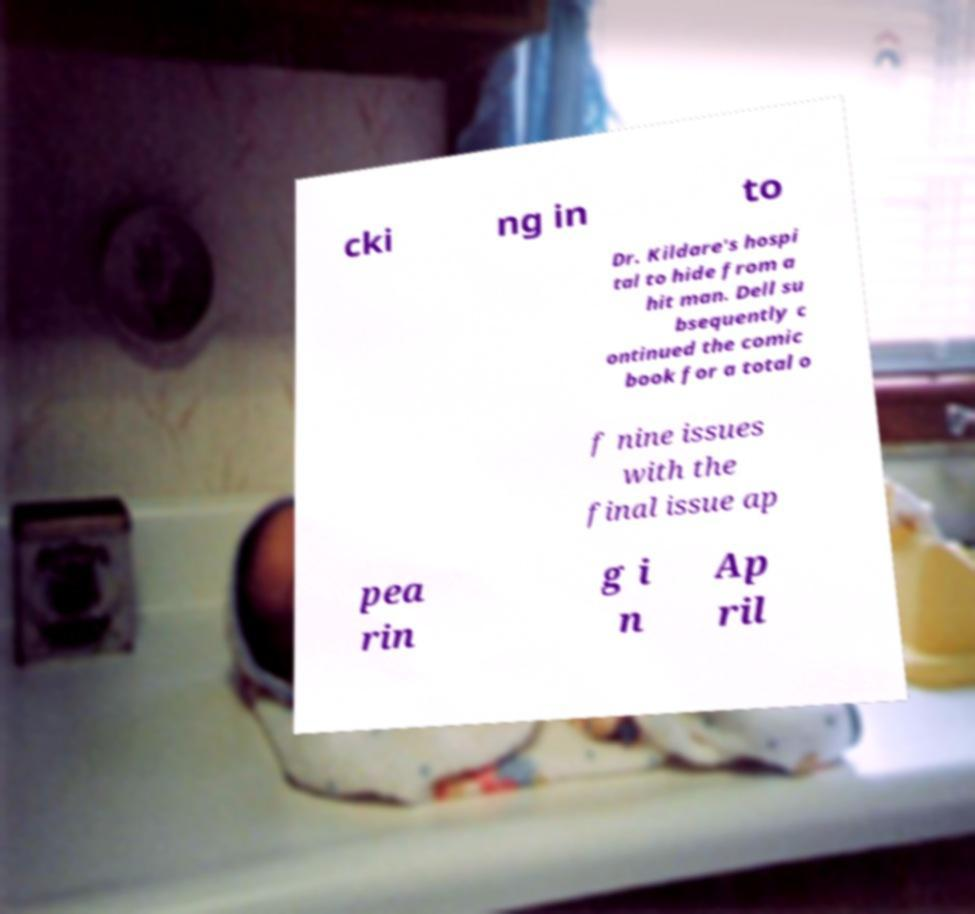Could you extract and type out the text from this image? cki ng in to Dr. Kildare's hospi tal to hide from a hit man. Dell su bsequently c ontinued the comic book for a total o f nine issues with the final issue ap pea rin g i n Ap ril 